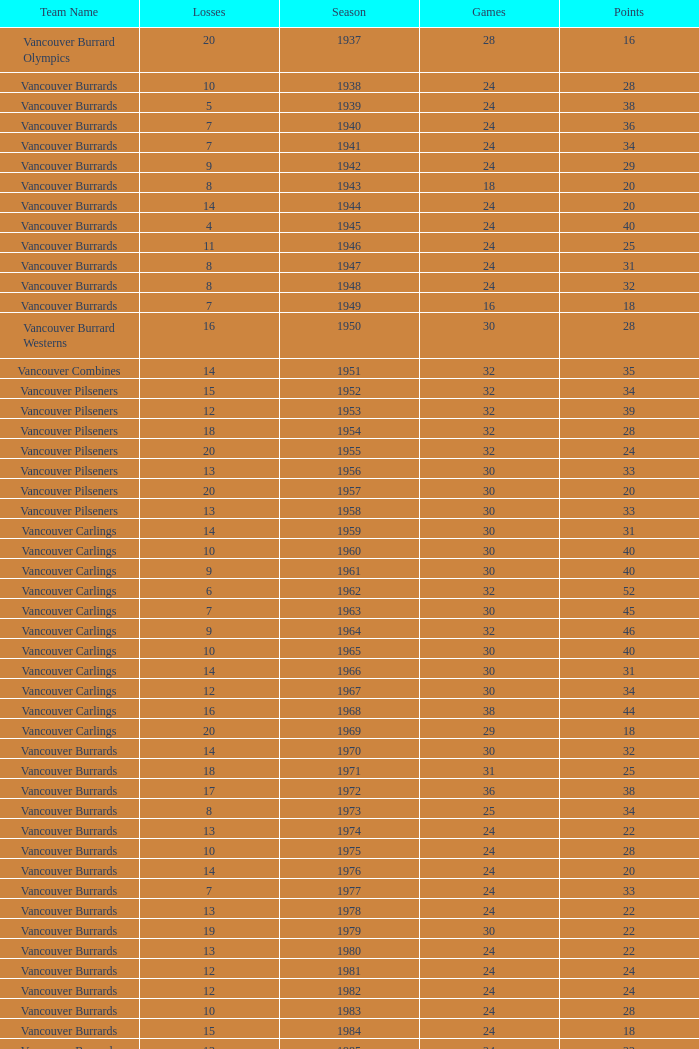What's the sum of points for the 1963 season when there are more than 30 games? None. 